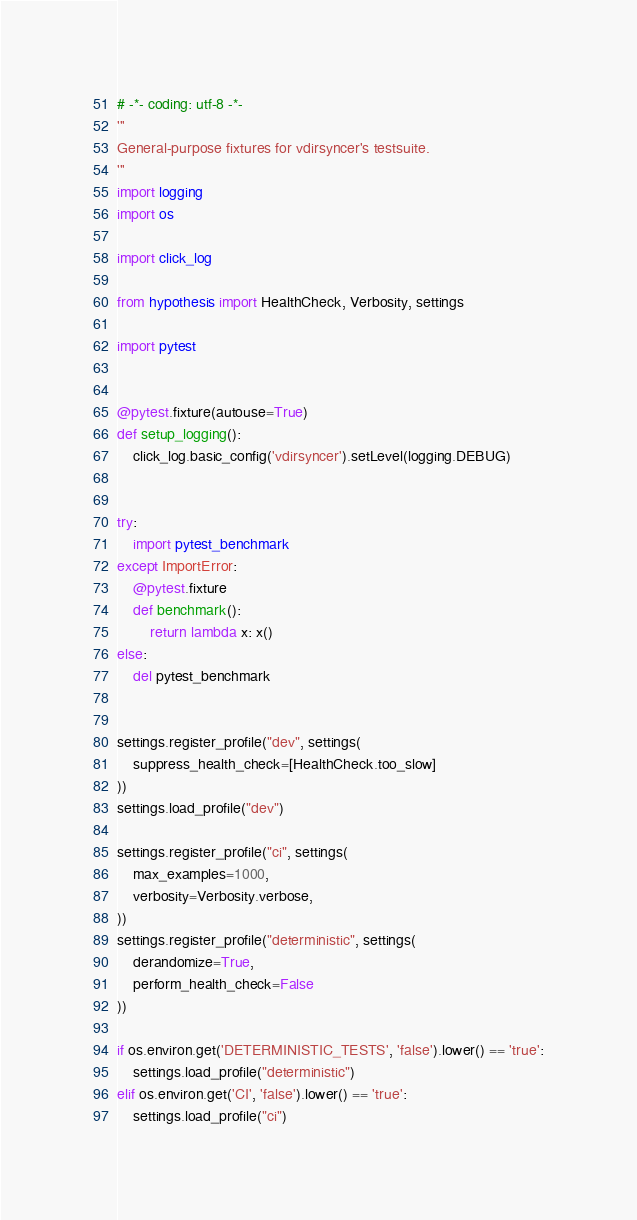Convert code to text. <code><loc_0><loc_0><loc_500><loc_500><_Python_># -*- coding: utf-8 -*-
'''
General-purpose fixtures for vdirsyncer's testsuite.
'''
import logging
import os

import click_log

from hypothesis import HealthCheck, Verbosity, settings

import pytest


@pytest.fixture(autouse=True)
def setup_logging():
    click_log.basic_config('vdirsyncer').setLevel(logging.DEBUG)


try:
    import pytest_benchmark
except ImportError:
    @pytest.fixture
    def benchmark():
        return lambda x: x()
else:
    del pytest_benchmark


settings.register_profile("dev", settings(
    suppress_health_check=[HealthCheck.too_slow]
))
settings.load_profile("dev")

settings.register_profile("ci", settings(
    max_examples=1000,
    verbosity=Verbosity.verbose,
))
settings.register_profile("deterministic", settings(
    derandomize=True,
    perform_health_check=False
))

if os.environ.get('DETERMINISTIC_TESTS', 'false').lower() == 'true':
    settings.load_profile("deterministic")
elif os.environ.get('CI', 'false').lower() == 'true':
    settings.load_profile("ci")
</code> 